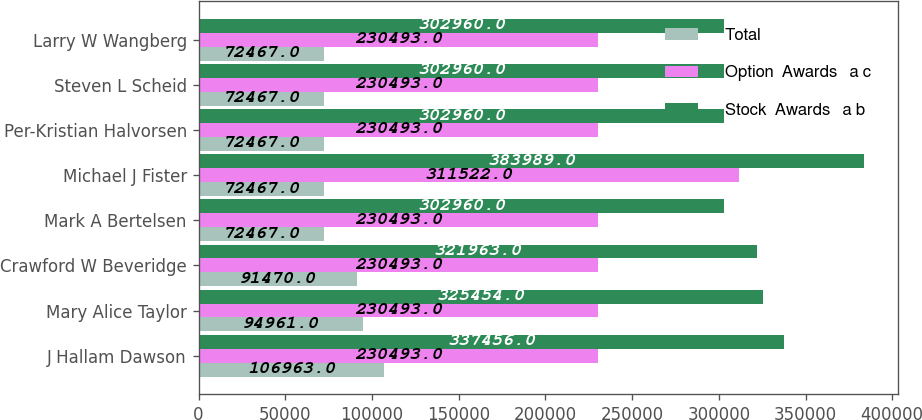Convert chart. <chart><loc_0><loc_0><loc_500><loc_500><stacked_bar_chart><ecel><fcel>J Hallam Dawson<fcel>Mary Alice Taylor<fcel>Crawford W Beveridge<fcel>Mark A Bertelsen<fcel>Michael J Fister<fcel>Per-Kristian Halvorsen<fcel>Steven L Scheid<fcel>Larry W Wangberg<nl><fcel>Total<fcel>106963<fcel>94961<fcel>91470<fcel>72467<fcel>72467<fcel>72467<fcel>72467<fcel>72467<nl><fcel>Option  Awards   a c<fcel>230493<fcel>230493<fcel>230493<fcel>230493<fcel>311522<fcel>230493<fcel>230493<fcel>230493<nl><fcel>Stock  Awards   a b<fcel>337456<fcel>325454<fcel>321963<fcel>302960<fcel>383989<fcel>302960<fcel>302960<fcel>302960<nl></chart> 